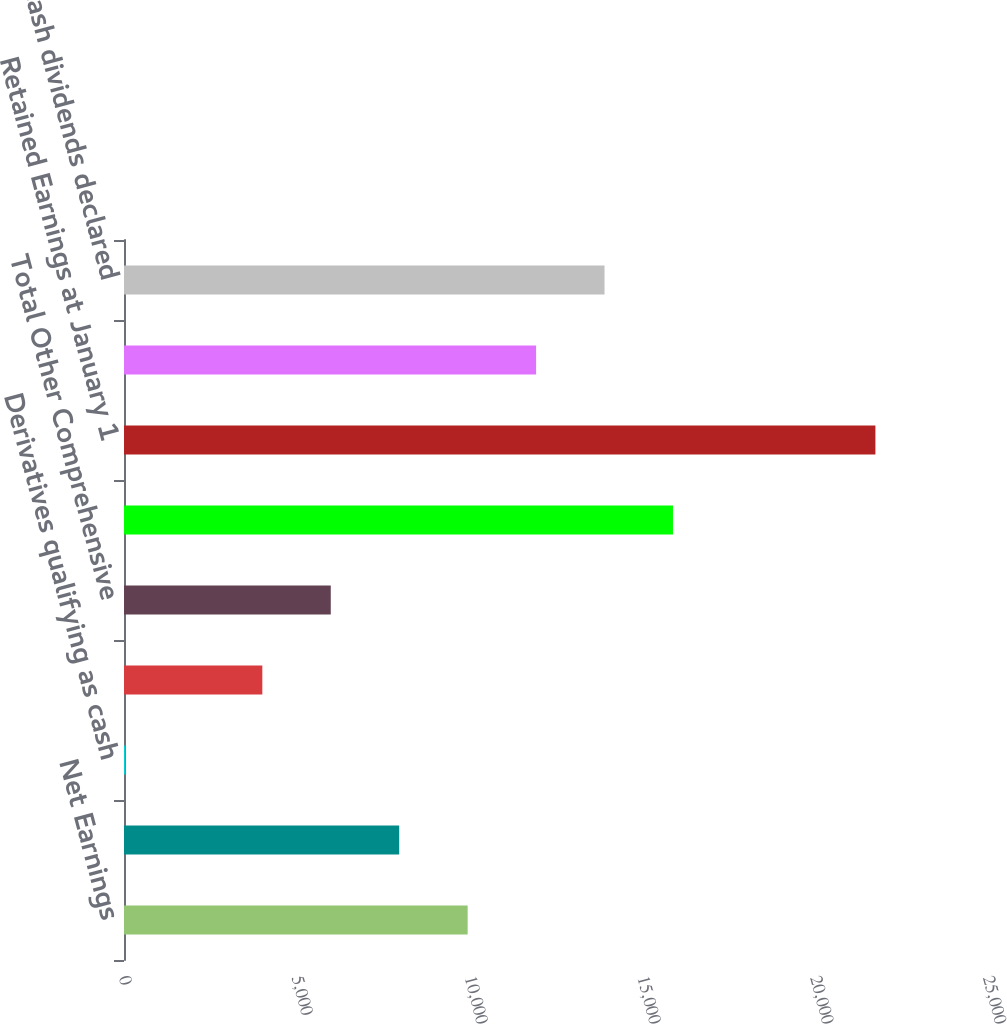Convert chart. <chart><loc_0><loc_0><loc_500><loc_500><bar_chart><fcel>Net Earnings<fcel>Foreign currency translation<fcel>Derivatives qualifying as cash<fcel>Available for sale securities<fcel>Total Other Comprehensive<fcel>Comprehensive Income<fcel>Retained Earnings at January 1<fcel>Net earnings<fcel>Cash dividends declared<nl><fcel>9943.5<fcel>7963.2<fcel>42<fcel>4002.6<fcel>5982.9<fcel>15884.4<fcel>21742.3<fcel>11923.8<fcel>13904.1<nl></chart> 